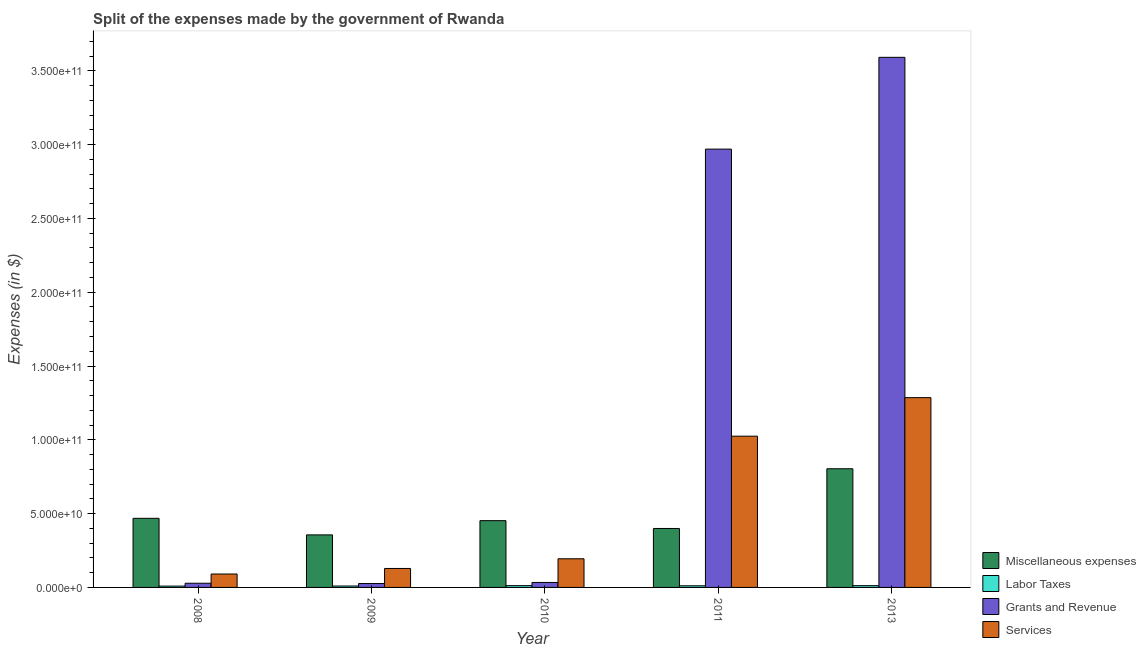In how many cases, is the number of bars for a given year not equal to the number of legend labels?
Your answer should be compact. 0. What is the amount spent on miscellaneous expenses in 2011?
Make the answer very short. 3.99e+1. Across all years, what is the maximum amount spent on miscellaneous expenses?
Provide a short and direct response. 8.04e+1. Across all years, what is the minimum amount spent on miscellaneous expenses?
Your answer should be very brief. 3.56e+1. In which year was the amount spent on services maximum?
Your response must be concise. 2013. In which year was the amount spent on services minimum?
Offer a terse response. 2008. What is the total amount spent on services in the graph?
Make the answer very short. 2.72e+11. What is the difference between the amount spent on services in 2008 and that in 2010?
Offer a very short reply. -1.03e+1. What is the difference between the amount spent on services in 2008 and the amount spent on miscellaneous expenses in 2011?
Your answer should be compact. -9.34e+1. What is the average amount spent on labor taxes per year?
Offer a very short reply. 1.07e+09. In the year 2011, what is the difference between the amount spent on labor taxes and amount spent on services?
Give a very brief answer. 0. What is the ratio of the amount spent on miscellaneous expenses in 2008 to that in 2013?
Keep it short and to the point. 0.58. What is the difference between the highest and the second highest amount spent on grants and revenue?
Provide a short and direct response. 6.22e+1. What is the difference between the highest and the lowest amount spent on services?
Your answer should be compact. 1.19e+11. In how many years, is the amount spent on miscellaneous expenses greater than the average amount spent on miscellaneous expenses taken over all years?
Make the answer very short. 1. Is it the case that in every year, the sum of the amount spent on miscellaneous expenses and amount spent on services is greater than the sum of amount spent on grants and revenue and amount spent on labor taxes?
Your response must be concise. Yes. What does the 4th bar from the left in 2013 represents?
Make the answer very short. Services. What does the 2nd bar from the right in 2010 represents?
Ensure brevity in your answer.  Grants and Revenue. How many bars are there?
Ensure brevity in your answer.  20. Are all the bars in the graph horizontal?
Provide a short and direct response. No. How many years are there in the graph?
Your answer should be compact. 5. Are the values on the major ticks of Y-axis written in scientific E-notation?
Provide a short and direct response. Yes. Does the graph contain grids?
Offer a terse response. No. What is the title of the graph?
Provide a short and direct response. Split of the expenses made by the government of Rwanda. Does "Rule based governance" appear as one of the legend labels in the graph?
Provide a succinct answer. No. What is the label or title of the X-axis?
Your answer should be compact. Year. What is the label or title of the Y-axis?
Ensure brevity in your answer.  Expenses (in $). What is the Expenses (in $) in Miscellaneous expenses in 2008?
Give a very brief answer. 4.68e+1. What is the Expenses (in $) of Labor Taxes in 2008?
Your response must be concise. 8.98e+08. What is the Expenses (in $) of Grants and Revenue in 2008?
Make the answer very short. 2.83e+09. What is the Expenses (in $) in Services in 2008?
Offer a very short reply. 9.09e+09. What is the Expenses (in $) of Miscellaneous expenses in 2009?
Give a very brief answer. 3.56e+1. What is the Expenses (in $) of Labor Taxes in 2009?
Provide a succinct answer. 9.60e+08. What is the Expenses (in $) in Grants and Revenue in 2009?
Keep it short and to the point. 2.63e+09. What is the Expenses (in $) of Services in 2009?
Provide a short and direct response. 1.28e+1. What is the Expenses (in $) in Miscellaneous expenses in 2010?
Your response must be concise. 4.52e+1. What is the Expenses (in $) of Labor Taxes in 2010?
Give a very brief answer. 1.21e+09. What is the Expenses (in $) in Grants and Revenue in 2010?
Your response must be concise. 3.37e+09. What is the Expenses (in $) in Services in 2010?
Your answer should be compact. 1.94e+1. What is the Expenses (in $) of Miscellaneous expenses in 2011?
Make the answer very short. 3.99e+1. What is the Expenses (in $) of Labor Taxes in 2011?
Ensure brevity in your answer.  1.11e+09. What is the Expenses (in $) of Grants and Revenue in 2011?
Give a very brief answer. 2.97e+11. What is the Expenses (in $) of Services in 2011?
Keep it short and to the point. 1.02e+11. What is the Expenses (in $) of Miscellaneous expenses in 2013?
Provide a succinct answer. 8.04e+1. What is the Expenses (in $) in Labor Taxes in 2013?
Provide a succinct answer. 1.20e+09. What is the Expenses (in $) in Grants and Revenue in 2013?
Provide a short and direct response. 3.59e+11. What is the Expenses (in $) of Services in 2013?
Provide a succinct answer. 1.29e+11. Across all years, what is the maximum Expenses (in $) of Miscellaneous expenses?
Provide a succinct answer. 8.04e+1. Across all years, what is the maximum Expenses (in $) in Labor Taxes?
Your answer should be compact. 1.21e+09. Across all years, what is the maximum Expenses (in $) in Grants and Revenue?
Your response must be concise. 3.59e+11. Across all years, what is the maximum Expenses (in $) of Services?
Your answer should be compact. 1.29e+11. Across all years, what is the minimum Expenses (in $) in Miscellaneous expenses?
Provide a succinct answer. 3.56e+1. Across all years, what is the minimum Expenses (in $) of Labor Taxes?
Provide a succinct answer. 8.98e+08. Across all years, what is the minimum Expenses (in $) of Grants and Revenue?
Provide a short and direct response. 2.63e+09. Across all years, what is the minimum Expenses (in $) in Services?
Provide a short and direct response. 9.09e+09. What is the total Expenses (in $) in Miscellaneous expenses in the graph?
Your answer should be compact. 2.48e+11. What is the total Expenses (in $) of Labor Taxes in the graph?
Your answer should be very brief. 5.37e+09. What is the total Expenses (in $) of Grants and Revenue in the graph?
Offer a very short reply. 6.65e+11. What is the total Expenses (in $) of Services in the graph?
Your answer should be very brief. 2.72e+11. What is the difference between the Expenses (in $) in Miscellaneous expenses in 2008 and that in 2009?
Ensure brevity in your answer.  1.12e+1. What is the difference between the Expenses (in $) in Labor Taxes in 2008 and that in 2009?
Give a very brief answer. -6.20e+07. What is the difference between the Expenses (in $) of Grants and Revenue in 2008 and that in 2009?
Your answer should be compact. 2.04e+08. What is the difference between the Expenses (in $) of Services in 2008 and that in 2009?
Your answer should be very brief. -3.76e+09. What is the difference between the Expenses (in $) of Miscellaneous expenses in 2008 and that in 2010?
Provide a succinct answer. 1.60e+09. What is the difference between the Expenses (in $) in Labor Taxes in 2008 and that in 2010?
Your answer should be compact. -3.12e+08. What is the difference between the Expenses (in $) in Grants and Revenue in 2008 and that in 2010?
Your response must be concise. -5.35e+08. What is the difference between the Expenses (in $) in Services in 2008 and that in 2010?
Give a very brief answer. -1.03e+1. What is the difference between the Expenses (in $) of Miscellaneous expenses in 2008 and that in 2011?
Ensure brevity in your answer.  6.88e+09. What is the difference between the Expenses (in $) of Labor Taxes in 2008 and that in 2011?
Keep it short and to the point. -2.09e+08. What is the difference between the Expenses (in $) in Grants and Revenue in 2008 and that in 2011?
Provide a short and direct response. -2.94e+11. What is the difference between the Expenses (in $) of Services in 2008 and that in 2011?
Offer a very short reply. -9.34e+1. What is the difference between the Expenses (in $) of Miscellaneous expenses in 2008 and that in 2013?
Keep it short and to the point. -3.36e+1. What is the difference between the Expenses (in $) in Labor Taxes in 2008 and that in 2013?
Provide a short and direct response. -2.97e+08. What is the difference between the Expenses (in $) in Grants and Revenue in 2008 and that in 2013?
Provide a short and direct response. -3.56e+11. What is the difference between the Expenses (in $) of Services in 2008 and that in 2013?
Ensure brevity in your answer.  -1.19e+11. What is the difference between the Expenses (in $) of Miscellaneous expenses in 2009 and that in 2010?
Provide a short and direct response. -9.63e+09. What is the difference between the Expenses (in $) in Labor Taxes in 2009 and that in 2010?
Your response must be concise. -2.50e+08. What is the difference between the Expenses (in $) of Grants and Revenue in 2009 and that in 2010?
Provide a succinct answer. -7.39e+08. What is the difference between the Expenses (in $) in Services in 2009 and that in 2010?
Offer a very short reply. -6.56e+09. What is the difference between the Expenses (in $) of Miscellaneous expenses in 2009 and that in 2011?
Provide a short and direct response. -4.34e+09. What is the difference between the Expenses (in $) of Labor Taxes in 2009 and that in 2011?
Provide a succinct answer. -1.47e+08. What is the difference between the Expenses (in $) in Grants and Revenue in 2009 and that in 2011?
Give a very brief answer. -2.94e+11. What is the difference between the Expenses (in $) in Services in 2009 and that in 2011?
Provide a succinct answer. -8.96e+1. What is the difference between the Expenses (in $) of Miscellaneous expenses in 2009 and that in 2013?
Ensure brevity in your answer.  -4.48e+1. What is the difference between the Expenses (in $) of Labor Taxes in 2009 and that in 2013?
Your answer should be very brief. -2.35e+08. What is the difference between the Expenses (in $) of Grants and Revenue in 2009 and that in 2013?
Keep it short and to the point. -3.57e+11. What is the difference between the Expenses (in $) of Services in 2009 and that in 2013?
Your answer should be compact. -1.16e+11. What is the difference between the Expenses (in $) in Miscellaneous expenses in 2010 and that in 2011?
Make the answer very short. 5.29e+09. What is the difference between the Expenses (in $) of Labor Taxes in 2010 and that in 2011?
Your response must be concise. 1.03e+08. What is the difference between the Expenses (in $) of Grants and Revenue in 2010 and that in 2011?
Give a very brief answer. -2.94e+11. What is the difference between the Expenses (in $) in Services in 2010 and that in 2011?
Your answer should be compact. -8.30e+1. What is the difference between the Expenses (in $) of Miscellaneous expenses in 2010 and that in 2013?
Your answer should be very brief. -3.52e+1. What is the difference between the Expenses (in $) in Labor Taxes in 2010 and that in 2013?
Provide a succinct answer. 1.46e+07. What is the difference between the Expenses (in $) of Grants and Revenue in 2010 and that in 2013?
Ensure brevity in your answer.  -3.56e+11. What is the difference between the Expenses (in $) of Services in 2010 and that in 2013?
Make the answer very short. -1.09e+11. What is the difference between the Expenses (in $) in Miscellaneous expenses in 2011 and that in 2013?
Your answer should be compact. -4.05e+1. What is the difference between the Expenses (in $) in Labor Taxes in 2011 and that in 2013?
Your response must be concise. -8.79e+07. What is the difference between the Expenses (in $) in Grants and Revenue in 2011 and that in 2013?
Provide a short and direct response. -6.22e+1. What is the difference between the Expenses (in $) in Services in 2011 and that in 2013?
Provide a succinct answer. -2.61e+1. What is the difference between the Expenses (in $) in Miscellaneous expenses in 2008 and the Expenses (in $) in Labor Taxes in 2009?
Ensure brevity in your answer.  4.59e+1. What is the difference between the Expenses (in $) in Miscellaneous expenses in 2008 and the Expenses (in $) in Grants and Revenue in 2009?
Offer a terse response. 4.42e+1. What is the difference between the Expenses (in $) in Miscellaneous expenses in 2008 and the Expenses (in $) in Services in 2009?
Give a very brief answer. 3.40e+1. What is the difference between the Expenses (in $) of Labor Taxes in 2008 and the Expenses (in $) of Grants and Revenue in 2009?
Your answer should be very brief. -1.73e+09. What is the difference between the Expenses (in $) in Labor Taxes in 2008 and the Expenses (in $) in Services in 2009?
Provide a succinct answer. -1.20e+1. What is the difference between the Expenses (in $) in Grants and Revenue in 2008 and the Expenses (in $) in Services in 2009?
Make the answer very short. -1.00e+1. What is the difference between the Expenses (in $) of Miscellaneous expenses in 2008 and the Expenses (in $) of Labor Taxes in 2010?
Offer a terse response. 4.56e+1. What is the difference between the Expenses (in $) in Miscellaneous expenses in 2008 and the Expenses (in $) in Grants and Revenue in 2010?
Your response must be concise. 4.35e+1. What is the difference between the Expenses (in $) of Miscellaneous expenses in 2008 and the Expenses (in $) of Services in 2010?
Offer a terse response. 2.74e+1. What is the difference between the Expenses (in $) of Labor Taxes in 2008 and the Expenses (in $) of Grants and Revenue in 2010?
Your answer should be compact. -2.47e+09. What is the difference between the Expenses (in $) of Labor Taxes in 2008 and the Expenses (in $) of Services in 2010?
Give a very brief answer. -1.85e+1. What is the difference between the Expenses (in $) in Grants and Revenue in 2008 and the Expenses (in $) in Services in 2010?
Make the answer very short. -1.66e+1. What is the difference between the Expenses (in $) in Miscellaneous expenses in 2008 and the Expenses (in $) in Labor Taxes in 2011?
Your answer should be very brief. 4.57e+1. What is the difference between the Expenses (in $) in Miscellaneous expenses in 2008 and the Expenses (in $) in Grants and Revenue in 2011?
Your answer should be compact. -2.50e+11. What is the difference between the Expenses (in $) of Miscellaneous expenses in 2008 and the Expenses (in $) of Services in 2011?
Provide a succinct answer. -5.56e+1. What is the difference between the Expenses (in $) in Labor Taxes in 2008 and the Expenses (in $) in Grants and Revenue in 2011?
Ensure brevity in your answer.  -2.96e+11. What is the difference between the Expenses (in $) of Labor Taxes in 2008 and the Expenses (in $) of Services in 2011?
Make the answer very short. -1.02e+11. What is the difference between the Expenses (in $) in Grants and Revenue in 2008 and the Expenses (in $) in Services in 2011?
Provide a succinct answer. -9.96e+1. What is the difference between the Expenses (in $) in Miscellaneous expenses in 2008 and the Expenses (in $) in Labor Taxes in 2013?
Provide a succinct answer. 4.56e+1. What is the difference between the Expenses (in $) in Miscellaneous expenses in 2008 and the Expenses (in $) in Grants and Revenue in 2013?
Offer a very short reply. -3.12e+11. What is the difference between the Expenses (in $) of Miscellaneous expenses in 2008 and the Expenses (in $) of Services in 2013?
Your answer should be compact. -8.18e+1. What is the difference between the Expenses (in $) in Labor Taxes in 2008 and the Expenses (in $) in Grants and Revenue in 2013?
Give a very brief answer. -3.58e+11. What is the difference between the Expenses (in $) in Labor Taxes in 2008 and the Expenses (in $) in Services in 2013?
Your answer should be compact. -1.28e+11. What is the difference between the Expenses (in $) of Grants and Revenue in 2008 and the Expenses (in $) of Services in 2013?
Keep it short and to the point. -1.26e+11. What is the difference between the Expenses (in $) of Miscellaneous expenses in 2009 and the Expenses (in $) of Labor Taxes in 2010?
Your answer should be very brief. 3.44e+1. What is the difference between the Expenses (in $) in Miscellaneous expenses in 2009 and the Expenses (in $) in Grants and Revenue in 2010?
Your response must be concise. 3.22e+1. What is the difference between the Expenses (in $) in Miscellaneous expenses in 2009 and the Expenses (in $) in Services in 2010?
Your response must be concise. 1.62e+1. What is the difference between the Expenses (in $) of Labor Taxes in 2009 and the Expenses (in $) of Grants and Revenue in 2010?
Offer a very short reply. -2.41e+09. What is the difference between the Expenses (in $) of Labor Taxes in 2009 and the Expenses (in $) of Services in 2010?
Your answer should be very brief. -1.85e+1. What is the difference between the Expenses (in $) in Grants and Revenue in 2009 and the Expenses (in $) in Services in 2010?
Ensure brevity in your answer.  -1.68e+1. What is the difference between the Expenses (in $) in Miscellaneous expenses in 2009 and the Expenses (in $) in Labor Taxes in 2011?
Provide a succinct answer. 3.45e+1. What is the difference between the Expenses (in $) in Miscellaneous expenses in 2009 and the Expenses (in $) in Grants and Revenue in 2011?
Your answer should be very brief. -2.61e+11. What is the difference between the Expenses (in $) of Miscellaneous expenses in 2009 and the Expenses (in $) of Services in 2011?
Provide a succinct answer. -6.69e+1. What is the difference between the Expenses (in $) of Labor Taxes in 2009 and the Expenses (in $) of Grants and Revenue in 2011?
Offer a terse response. -2.96e+11. What is the difference between the Expenses (in $) in Labor Taxes in 2009 and the Expenses (in $) in Services in 2011?
Make the answer very short. -1.02e+11. What is the difference between the Expenses (in $) of Grants and Revenue in 2009 and the Expenses (in $) of Services in 2011?
Offer a terse response. -9.98e+1. What is the difference between the Expenses (in $) in Miscellaneous expenses in 2009 and the Expenses (in $) in Labor Taxes in 2013?
Provide a succinct answer. 3.44e+1. What is the difference between the Expenses (in $) in Miscellaneous expenses in 2009 and the Expenses (in $) in Grants and Revenue in 2013?
Your response must be concise. -3.24e+11. What is the difference between the Expenses (in $) in Miscellaneous expenses in 2009 and the Expenses (in $) in Services in 2013?
Ensure brevity in your answer.  -9.30e+1. What is the difference between the Expenses (in $) of Labor Taxes in 2009 and the Expenses (in $) of Grants and Revenue in 2013?
Offer a very short reply. -3.58e+11. What is the difference between the Expenses (in $) of Labor Taxes in 2009 and the Expenses (in $) of Services in 2013?
Make the answer very short. -1.28e+11. What is the difference between the Expenses (in $) in Grants and Revenue in 2009 and the Expenses (in $) in Services in 2013?
Provide a short and direct response. -1.26e+11. What is the difference between the Expenses (in $) of Miscellaneous expenses in 2010 and the Expenses (in $) of Labor Taxes in 2011?
Offer a very short reply. 4.41e+1. What is the difference between the Expenses (in $) in Miscellaneous expenses in 2010 and the Expenses (in $) in Grants and Revenue in 2011?
Make the answer very short. -2.52e+11. What is the difference between the Expenses (in $) in Miscellaneous expenses in 2010 and the Expenses (in $) in Services in 2011?
Your answer should be very brief. -5.72e+1. What is the difference between the Expenses (in $) of Labor Taxes in 2010 and the Expenses (in $) of Grants and Revenue in 2011?
Offer a terse response. -2.96e+11. What is the difference between the Expenses (in $) of Labor Taxes in 2010 and the Expenses (in $) of Services in 2011?
Your response must be concise. -1.01e+11. What is the difference between the Expenses (in $) in Grants and Revenue in 2010 and the Expenses (in $) in Services in 2011?
Keep it short and to the point. -9.91e+1. What is the difference between the Expenses (in $) of Miscellaneous expenses in 2010 and the Expenses (in $) of Labor Taxes in 2013?
Make the answer very short. 4.40e+1. What is the difference between the Expenses (in $) in Miscellaneous expenses in 2010 and the Expenses (in $) in Grants and Revenue in 2013?
Offer a terse response. -3.14e+11. What is the difference between the Expenses (in $) in Miscellaneous expenses in 2010 and the Expenses (in $) in Services in 2013?
Your answer should be very brief. -8.33e+1. What is the difference between the Expenses (in $) of Labor Taxes in 2010 and the Expenses (in $) of Grants and Revenue in 2013?
Make the answer very short. -3.58e+11. What is the difference between the Expenses (in $) of Labor Taxes in 2010 and the Expenses (in $) of Services in 2013?
Provide a short and direct response. -1.27e+11. What is the difference between the Expenses (in $) in Grants and Revenue in 2010 and the Expenses (in $) in Services in 2013?
Give a very brief answer. -1.25e+11. What is the difference between the Expenses (in $) in Miscellaneous expenses in 2011 and the Expenses (in $) in Labor Taxes in 2013?
Ensure brevity in your answer.  3.87e+1. What is the difference between the Expenses (in $) in Miscellaneous expenses in 2011 and the Expenses (in $) in Grants and Revenue in 2013?
Offer a terse response. -3.19e+11. What is the difference between the Expenses (in $) of Miscellaneous expenses in 2011 and the Expenses (in $) of Services in 2013?
Provide a succinct answer. -8.86e+1. What is the difference between the Expenses (in $) of Labor Taxes in 2011 and the Expenses (in $) of Grants and Revenue in 2013?
Give a very brief answer. -3.58e+11. What is the difference between the Expenses (in $) in Labor Taxes in 2011 and the Expenses (in $) in Services in 2013?
Give a very brief answer. -1.27e+11. What is the difference between the Expenses (in $) of Grants and Revenue in 2011 and the Expenses (in $) of Services in 2013?
Provide a succinct answer. 1.68e+11. What is the average Expenses (in $) in Miscellaneous expenses per year?
Offer a very short reply. 4.96e+1. What is the average Expenses (in $) in Labor Taxes per year?
Make the answer very short. 1.07e+09. What is the average Expenses (in $) in Grants and Revenue per year?
Provide a short and direct response. 1.33e+11. What is the average Expenses (in $) in Services per year?
Offer a very short reply. 5.45e+1. In the year 2008, what is the difference between the Expenses (in $) of Miscellaneous expenses and Expenses (in $) of Labor Taxes?
Offer a terse response. 4.59e+1. In the year 2008, what is the difference between the Expenses (in $) of Miscellaneous expenses and Expenses (in $) of Grants and Revenue?
Make the answer very short. 4.40e+1. In the year 2008, what is the difference between the Expenses (in $) in Miscellaneous expenses and Expenses (in $) in Services?
Make the answer very short. 3.77e+1. In the year 2008, what is the difference between the Expenses (in $) of Labor Taxes and Expenses (in $) of Grants and Revenue?
Your response must be concise. -1.94e+09. In the year 2008, what is the difference between the Expenses (in $) of Labor Taxes and Expenses (in $) of Services?
Your answer should be very brief. -8.19e+09. In the year 2008, what is the difference between the Expenses (in $) of Grants and Revenue and Expenses (in $) of Services?
Offer a terse response. -6.26e+09. In the year 2009, what is the difference between the Expenses (in $) of Miscellaneous expenses and Expenses (in $) of Labor Taxes?
Your answer should be very brief. 3.46e+1. In the year 2009, what is the difference between the Expenses (in $) of Miscellaneous expenses and Expenses (in $) of Grants and Revenue?
Give a very brief answer. 3.30e+1. In the year 2009, what is the difference between the Expenses (in $) in Miscellaneous expenses and Expenses (in $) in Services?
Offer a terse response. 2.27e+1. In the year 2009, what is the difference between the Expenses (in $) of Labor Taxes and Expenses (in $) of Grants and Revenue?
Make the answer very short. -1.67e+09. In the year 2009, what is the difference between the Expenses (in $) in Labor Taxes and Expenses (in $) in Services?
Give a very brief answer. -1.19e+1. In the year 2009, what is the difference between the Expenses (in $) of Grants and Revenue and Expenses (in $) of Services?
Keep it short and to the point. -1.02e+1. In the year 2010, what is the difference between the Expenses (in $) of Miscellaneous expenses and Expenses (in $) of Labor Taxes?
Provide a short and direct response. 4.40e+1. In the year 2010, what is the difference between the Expenses (in $) in Miscellaneous expenses and Expenses (in $) in Grants and Revenue?
Your answer should be compact. 4.19e+1. In the year 2010, what is the difference between the Expenses (in $) of Miscellaneous expenses and Expenses (in $) of Services?
Provide a succinct answer. 2.58e+1. In the year 2010, what is the difference between the Expenses (in $) in Labor Taxes and Expenses (in $) in Grants and Revenue?
Provide a succinct answer. -2.16e+09. In the year 2010, what is the difference between the Expenses (in $) in Labor Taxes and Expenses (in $) in Services?
Ensure brevity in your answer.  -1.82e+1. In the year 2010, what is the difference between the Expenses (in $) in Grants and Revenue and Expenses (in $) in Services?
Offer a very short reply. -1.60e+1. In the year 2011, what is the difference between the Expenses (in $) of Miscellaneous expenses and Expenses (in $) of Labor Taxes?
Give a very brief answer. 3.88e+1. In the year 2011, what is the difference between the Expenses (in $) of Miscellaneous expenses and Expenses (in $) of Grants and Revenue?
Offer a very short reply. -2.57e+11. In the year 2011, what is the difference between the Expenses (in $) in Miscellaneous expenses and Expenses (in $) in Services?
Provide a short and direct response. -6.25e+1. In the year 2011, what is the difference between the Expenses (in $) of Labor Taxes and Expenses (in $) of Grants and Revenue?
Keep it short and to the point. -2.96e+11. In the year 2011, what is the difference between the Expenses (in $) of Labor Taxes and Expenses (in $) of Services?
Your answer should be compact. -1.01e+11. In the year 2011, what is the difference between the Expenses (in $) in Grants and Revenue and Expenses (in $) in Services?
Your answer should be very brief. 1.94e+11. In the year 2013, what is the difference between the Expenses (in $) in Miscellaneous expenses and Expenses (in $) in Labor Taxes?
Make the answer very short. 7.92e+1. In the year 2013, what is the difference between the Expenses (in $) of Miscellaneous expenses and Expenses (in $) of Grants and Revenue?
Provide a short and direct response. -2.79e+11. In the year 2013, what is the difference between the Expenses (in $) of Miscellaneous expenses and Expenses (in $) of Services?
Offer a very short reply. -4.82e+1. In the year 2013, what is the difference between the Expenses (in $) in Labor Taxes and Expenses (in $) in Grants and Revenue?
Keep it short and to the point. -3.58e+11. In the year 2013, what is the difference between the Expenses (in $) of Labor Taxes and Expenses (in $) of Services?
Provide a succinct answer. -1.27e+11. In the year 2013, what is the difference between the Expenses (in $) of Grants and Revenue and Expenses (in $) of Services?
Your answer should be very brief. 2.31e+11. What is the ratio of the Expenses (in $) in Miscellaneous expenses in 2008 to that in 2009?
Keep it short and to the point. 1.32. What is the ratio of the Expenses (in $) of Labor Taxes in 2008 to that in 2009?
Ensure brevity in your answer.  0.94. What is the ratio of the Expenses (in $) in Grants and Revenue in 2008 to that in 2009?
Keep it short and to the point. 1.08. What is the ratio of the Expenses (in $) in Services in 2008 to that in 2009?
Keep it short and to the point. 0.71. What is the ratio of the Expenses (in $) in Miscellaneous expenses in 2008 to that in 2010?
Make the answer very short. 1.04. What is the ratio of the Expenses (in $) in Labor Taxes in 2008 to that in 2010?
Your answer should be compact. 0.74. What is the ratio of the Expenses (in $) of Grants and Revenue in 2008 to that in 2010?
Offer a terse response. 0.84. What is the ratio of the Expenses (in $) of Services in 2008 to that in 2010?
Provide a succinct answer. 0.47. What is the ratio of the Expenses (in $) in Miscellaneous expenses in 2008 to that in 2011?
Offer a very short reply. 1.17. What is the ratio of the Expenses (in $) of Labor Taxes in 2008 to that in 2011?
Offer a terse response. 0.81. What is the ratio of the Expenses (in $) of Grants and Revenue in 2008 to that in 2011?
Offer a very short reply. 0.01. What is the ratio of the Expenses (in $) in Services in 2008 to that in 2011?
Offer a very short reply. 0.09. What is the ratio of the Expenses (in $) in Miscellaneous expenses in 2008 to that in 2013?
Keep it short and to the point. 0.58. What is the ratio of the Expenses (in $) in Labor Taxes in 2008 to that in 2013?
Give a very brief answer. 0.75. What is the ratio of the Expenses (in $) in Grants and Revenue in 2008 to that in 2013?
Your response must be concise. 0.01. What is the ratio of the Expenses (in $) in Services in 2008 to that in 2013?
Ensure brevity in your answer.  0.07. What is the ratio of the Expenses (in $) of Miscellaneous expenses in 2009 to that in 2010?
Provide a short and direct response. 0.79. What is the ratio of the Expenses (in $) of Labor Taxes in 2009 to that in 2010?
Provide a short and direct response. 0.79. What is the ratio of the Expenses (in $) in Grants and Revenue in 2009 to that in 2010?
Offer a very short reply. 0.78. What is the ratio of the Expenses (in $) in Services in 2009 to that in 2010?
Offer a terse response. 0.66. What is the ratio of the Expenses (in $) in Miscellaneous expenses in 2009 to that in 2011?
Ensure brevity in your answer.  0.89. What is the ratio of the Expenses (in $) in Labor Taxes in 2009 to that in 2011?
Your answer should be compact. 0.87. What is the ratio of the Expenses (in $) in Grants and Revenue in 2009 to that in 2011?
Provide a succinct answer. 0.01. What is the ratio of the Expenses (in $) in Services in 2009 to that in 2011?
Keep it short and to the point. 0.13. What is the ratio of the Expenses (in $) of Miscellaneous expenses in 2009 to that in 2013?
Give a very brief answer. 0.44. What is the ratio of the Expenses (in $) of Labor Taxes in 2009 to that in 2013?
Make the answer very short. 0.8. What is the ratio of the Expenses (in $) in Grants and Revenue in 2009 to that in 2013?
Make the answer very short. 0.01. What is the ratio of the Expenses (in $) of Services in 2009 to that in 2013?
Provide a short and direct response. 0.1. What is the ratio of the Expenses (in $) of Miscellaneous expenses in 2010 to that in 2011?
Give a very brief answer. 1.13. What is the ratio of the Expenses (in $) of Labor Taxes in 2010 to that in 2011?
Keep it short and to the point. 1.09. What is the ratio of the Expenses (in $) in Grants and Revenue in 2010 to that in 2011?
Your answer should be very brief. 0.01. What is the ratio of the Expenses (in $) in Services in 2010 to that in 2011?
Give a very brief answer. 0.19. What is the ratio of the Expenses (in $) in Miscellaneous expenses in 2010 to that in 2013?
Your answer should be very brief. 0.56. What is the ratio of the Expenses (in $) of Labor Taxes in 2010 to that in 2013?
Your answer should be very brief. 1.01. What is the ratio of the Expenses (in $) of Grants and Revenue in 2010 to that in 2013?
Provide a short and direct response. 0.01. What is the ratio of the Expenses (in $) in Services in 2010 to that in 2013?
Provide a succinct answer. 0.15. What is the ratio of the Expenses (in $) of Miscellaneous expenses in 2011 to that in 2013?
Provide a succinct answer. 0.5. What is the ratio of the Expenses (in $) of Labor Taxes in 2011 to that in 2013?
Give a very brief answer. 0.93. What is the ratio of the Expenses (in $) of Grants and Revenue in 2011 to that in 2013?
Make the answer very short. 0.83. What is the ratio of the Expenses (in $) in Services in 2011 to that in 2013?
Make the answer very short. 0.8. What is the difference between the highest and the second highest Expenses (in $) of Miscellaneous expenses?
Your answer should be very brief. 3.36e+1. What is the difference between the highest and the second highest Expenses (in $) of Labor Taxes?
Your response must be concise. 1.46e+07. What is the difference between the highest and the second highest Expenses (in $) of Grants and Revenue?
Offer a very short reply. 6.22e+1. What is the difference between the highest and the second highest Expenses (in $) of Services?
Ensure brevity in your answer.  2.61e+1. What is the difference between the highest and the lowest Expenses (in $) in Miscellaneous expenses?
Your answer should be very brief. 4.48e+1. What is the difference between the highest and the lowest Expenses (in $) in Labor Taxes?
Offer a very short reply. 3.12e+08. What is the difference between the highest and the lowest Expenses (in $) of Grants and Revenue?
Ensure brevity in your answer.  3.57e+11. What is the difference between the highest and the lowest Expenses (in $) in Services?
Ensure brevity in your answer.  1.19e+11. 